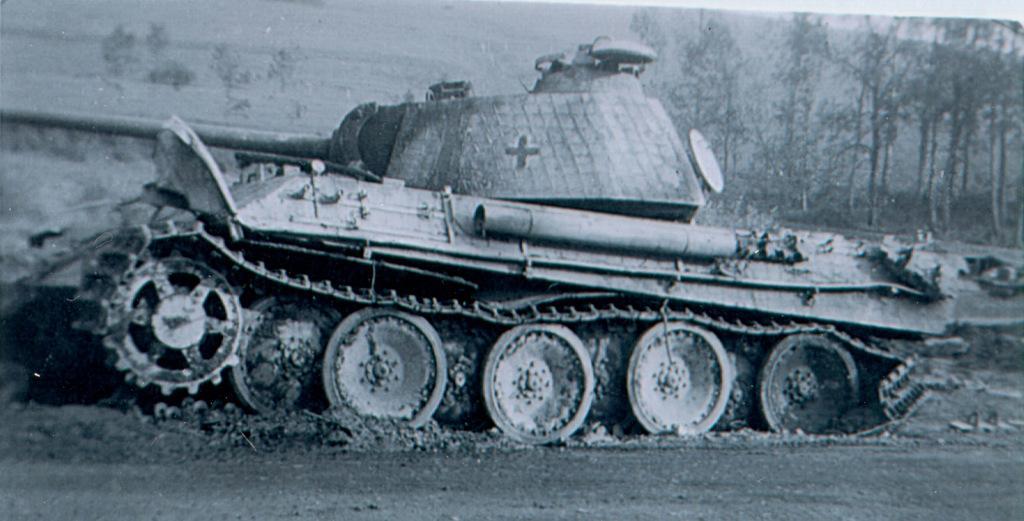Please provide a concise description of this image. In this image we can see a vehicle. In the background there are trees. 